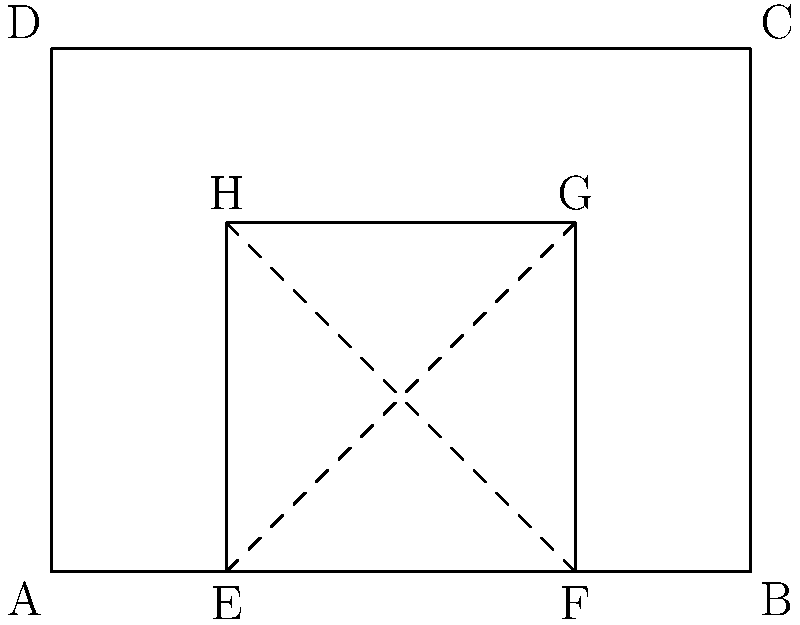In the decorative pattern of a Torii gate at Ise Grand Shrine, a rectangular frame ABCD contains a smaller rectangle EFGH. If AB = 4 units, BC = 3 units, and EF = 2 units, what is the ratio of the area of rectangle EFGH to the area of rectangle ABCD? Let's solve this step-by-step:

1) First, we need to calculate the areas of both rectangles.

2) For rectangle ABCD:
   Area of ABCD = AB × BC = 4 × 3 = 12 square units

3) For rectangle EFGH:
   We know EF = 2 units, but we need to find EH.
   
4) We can see that EF:AB = EH:BC (similar triangles)
   2:4 = EH:3
   EH = (2 × 3) ÷ 4 = 1.5 units

5) Now we can calculate the area of EFGH:
   Area of EFGH = EF × EH = 2 × 1.5 = 3 square units

6) The ratio of the areas is:
   Area of EFGH : Area of ABCD = 3 : 12

7) This can be simplified to:
   1 : 4

Therefore, the ratio of the area of rectangle EFGH to the area of rectangle ABCD is 1:4.
Answer: 1:4 